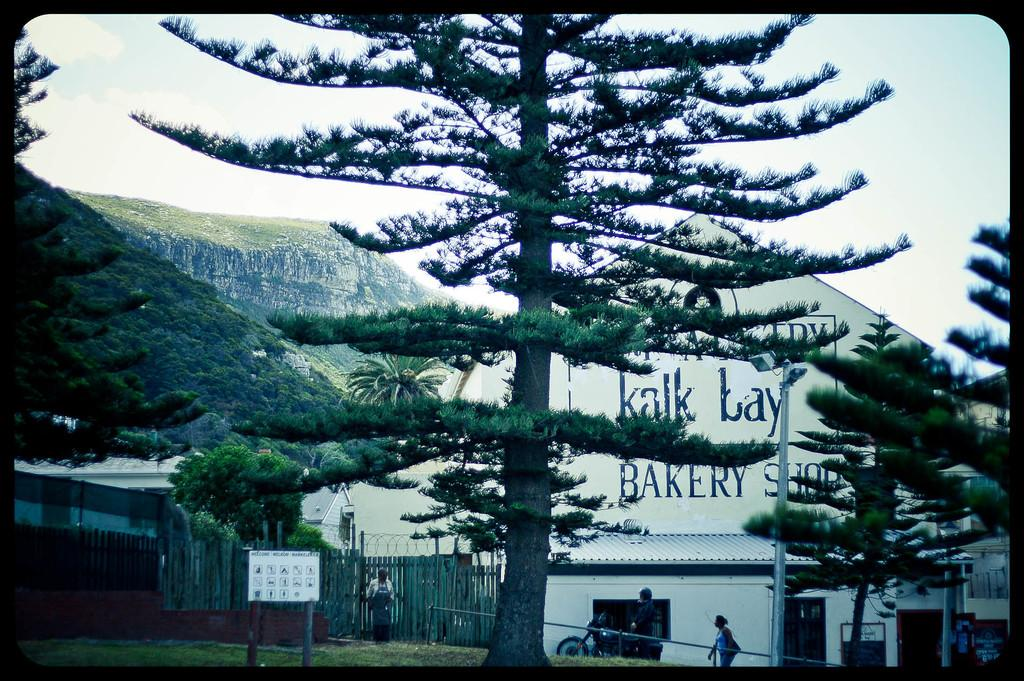What is the main object in the image? There is a board in the image. Who or what is behind the board? There are people behind the board. What type of natural elements can be seen in the image? There are trees in the image. What type of man-made structures are visible in the image? There are buildings in the image. What type of barrier is present in the image? There is a metal fence in the image. What type of lighting is present in the image? There are street lights in the image. What can be seen in the background of the image? The sky is visible in the background of the image. What type of dinosaurs can be seen in the image? There are no dinosaurs present in the image. What type of activity are the people behind the board engaged in? The provided facts do not mention any specific activity that the people are engaged in. 